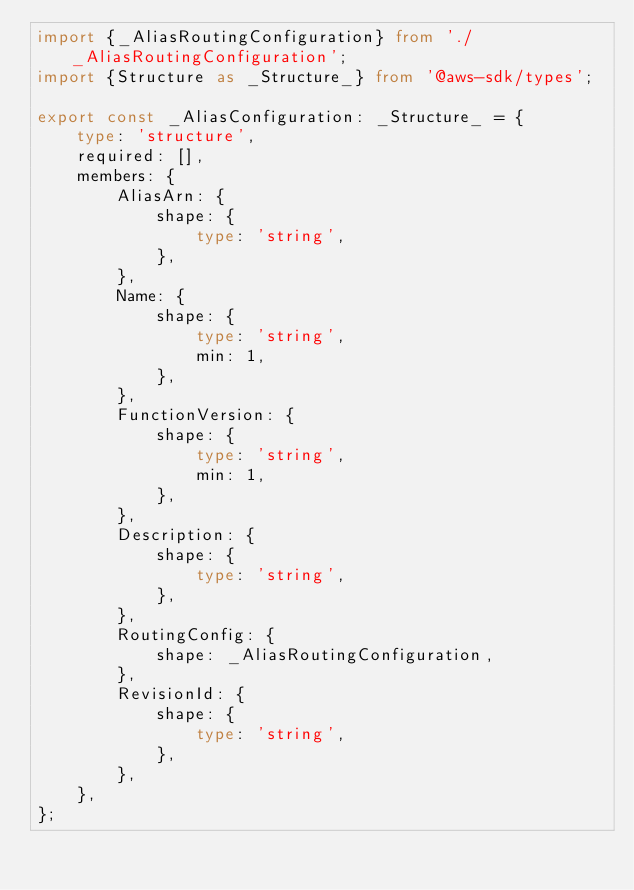Convert code to text. <code><loc_0><loc_0><loc_500><loc_500><_TypeScript_>import {_AliasRoutingConfiguration} from './_AliasRoutingConfiguration';
import {Structure as _Structure_} from '@aws-sdk/types';

export const _AliasConfiguration: _Structure_ = {
    type: 'structure',
    required: [],
    members: {
        AliasArn: {
            shape: {
                type: 'string',
            },
        },
        Name: {
            shape: {
                type: 'string',
                min: 1,
            },
        },
        FunctionVersion: {
            shape: {
                type: 'string',
                min: 1,
            },
        },
        Description: {
            shape: {
                type: 'string',
            },
        },
        RoutingConfig: {
            shape: _AliasRoutingConfiguration,
        },
        RevisionId: {
            shape: {
                type: 'string',
            },
        },
    },
};</code> 